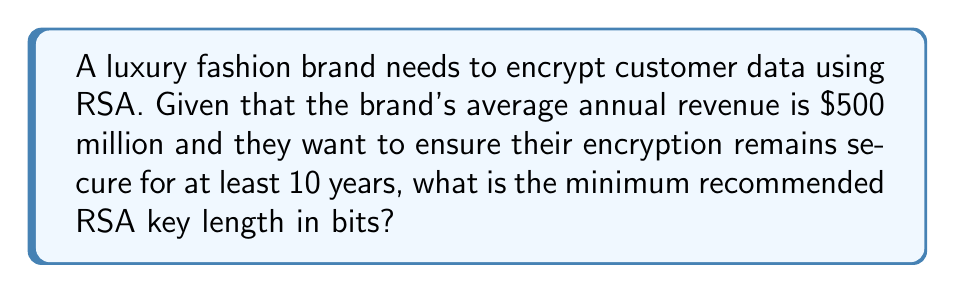Teach me how to tackle this problem. To determine the optimal RSA key length, we need to consider several factors:

1. Security level: For a luxury brand with high revenue, we should aim for a high security level. Let's use 128-bit security as our target.

2. Time frame: The brand wants encryption to remain secure for at least 10 years.

3. Moore's Law: Computing power roughly doubles every 18 months. We need to account for this increase over the 10-year period.

4. NIST recommendations: We'll use NIST guidelines for key lengths.

Step 1: Calculate the effective security level needed after 10 years.
Number of doublings in 10 years: $\frac{10 \text{ years}}{1.5 \text{ years}} \approx 6.67$
Effective security level: $128 \times 2^{6.67} \approx 1638$ bits

Step 2: Use NIST recommendations to map this security level to RSA key length.
NIST recommends:
- 112-bit security: 2048-bit RSA
- 128-bit security: 3072-bit RSA
- 192-bit security: 7680-bit RSA
- 256-bit security: 15360-bit RSA

Step 3: Interpolate between these values to find the appropriate key length.
Our calculated security level (1638 bits) falls between 192-bit and 256-bit security.

Interpolation:
$$(15360 - 7680) \times \frac{1638 - 192}{256 - 192} + 7680 \approx 13977$$

Therefore, the minimum recommended RSA key length is approximately 13977 bits. Rounding up to the nearest standard key size, we get 15360 bits.
Answer: 15360 bits 